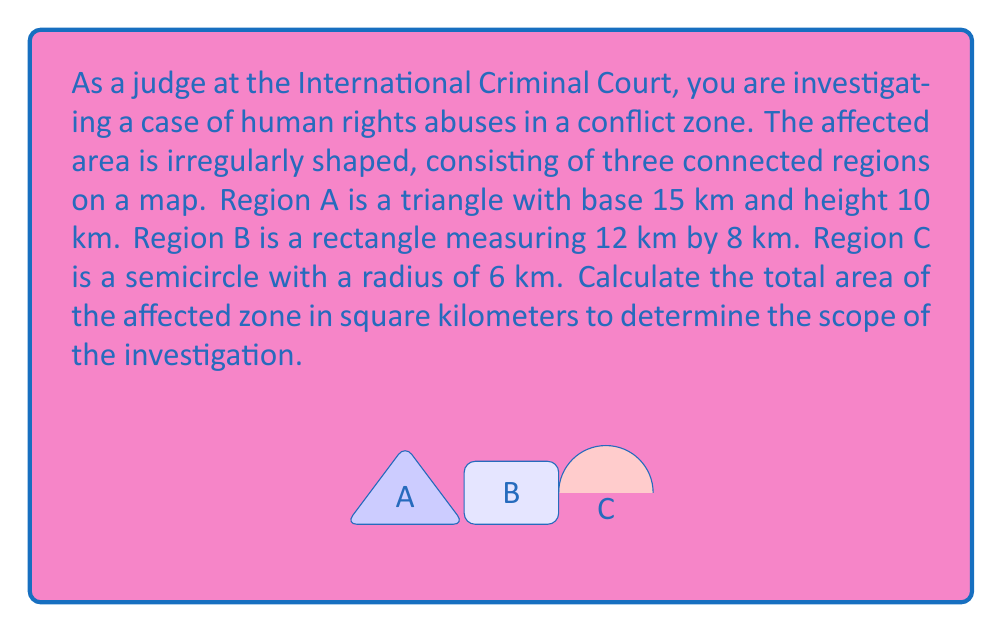Teach me how to tackle this problem. To calculate the total area of the affected zone, we need to determine the areas of each region and sum them up.

1. Region A (Triangle):
   Area of a triangle = $\frac{1}{2} \times base \times height$
   $$A_A = \frac{1}{2} \times 15 \times 10 = 75 \text{ km}^2$$

2. Region B (Rectangle):
   Area of a rectangle = length $\times$ width
   $$A_B = 12 \times 8 = 96 \text{ km}^2$$

3. Region C (Semicircle):
   Area of a semicircle = $\frac{1}{2} \times \pi r^2$
   $$A_C = \frac{1}{2} \times \pi \times 6^2 = 18\pi \text{ km}^2$$

Now, we sum up the areas of all three regions:

$$\begin{align*}
A_{total} &= A_A + A_B + A_C \\
&= 75 + 96 + 18\pi \\
&= 171 + 18\pi \text{ km}^2 \\
&\approx 227.57 \text{ km}^2
\end{align*}$$
Answer: The total area of the affected zone is $171 + 18\pi \text{ km}^2$ or approximately 227.57 km². 